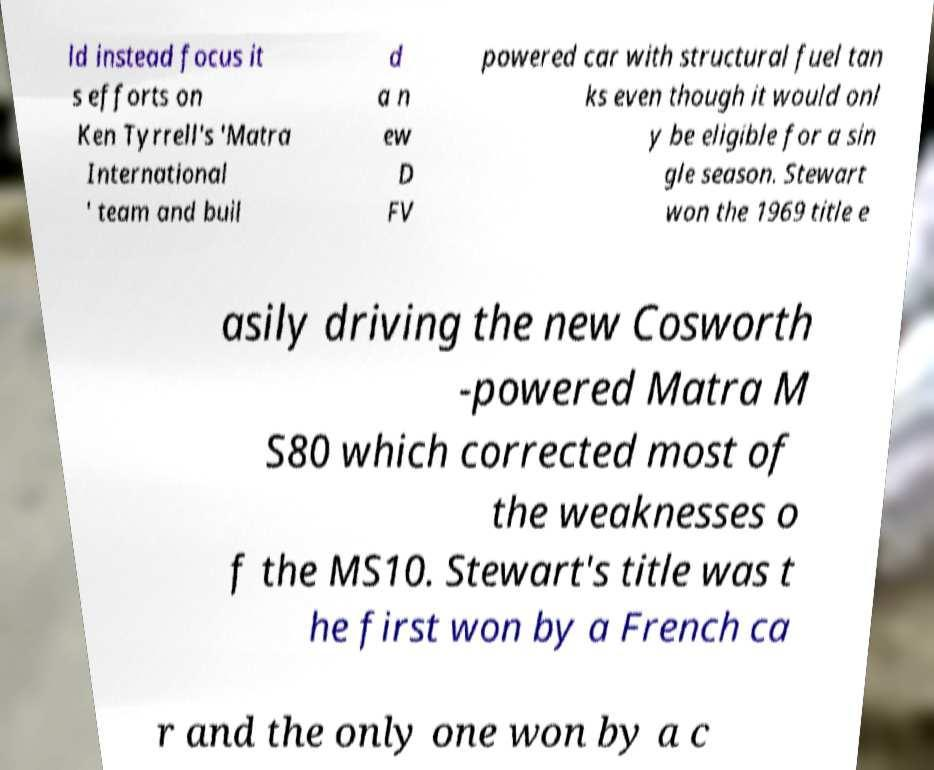Please read and relay the text visible in this image. What does it say? ld instead focus it s efforts on Ken Tyrrell's 'Matra International ' team and buil d a n ew D FV powered car with structural fuel tan ks even though it would onl y be eligible for a sin gle season. Stewart won the 1969 title e asily driving the new Cosworth -powered Matra M S80 which corrected most of the weaknesses o f the MS10. Stewart's title was t he first won by a French ca r and the only one won by a c 